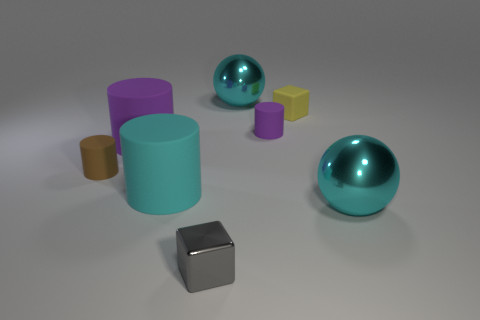How many things are either tiny blocks to the right of the tiny gray shiny thing or tiny yellow shiny blocks?
Your answer should be very brief. 1. What material is the object in front of the cyan object in front of the cyan matte object?
Make the answer very short. Metal. Are there any tiny purple things of the same shape as the brown thing?
Give a very brief answer. Yes. There is a yellow thing; does it have the same size as the purple cylinder that is on the left side of the cyan rubber cylinder?
Offer a terse response. No. How many things are either big shiny balls that are on the left side of the matte block or cubes that are in front of the cyan rubber cylinder?
Provide a short and direct response. 2. Is the number of tiny brown cylinders that are right of the cyan matte object greater than the number of rubber objects?
Make the answer very short. No. How many purple objects are the same size as the brown thing?
Your answer should be very brief. 1. Is the size of the cyan sphere on the left side of the yellow block the same as the purple matte object that is to the left of the cyan cylinder?
Ensure brevity in your answer.  Yes. There is a cyan metallic thing in front of the cyan cylinder; what size is it?
Give a very brief answer. Large. What is the size of the shiny thing that is on the right side of the tiny rubber cylinder that is on the right side of the brown object?
Give a very brief answer. Large. 